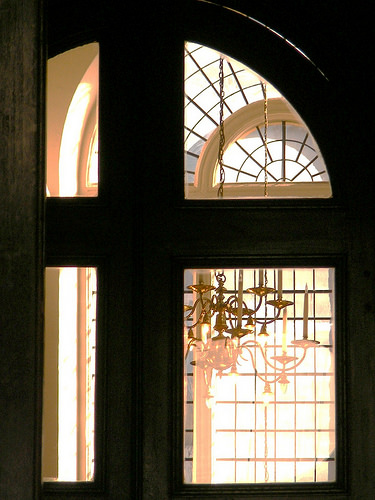<image>
Can you confirm if the chandelier is in front of the window? No. The chandelier is not in front of the window. The spatial positioning shows a different relationship between these objects. 